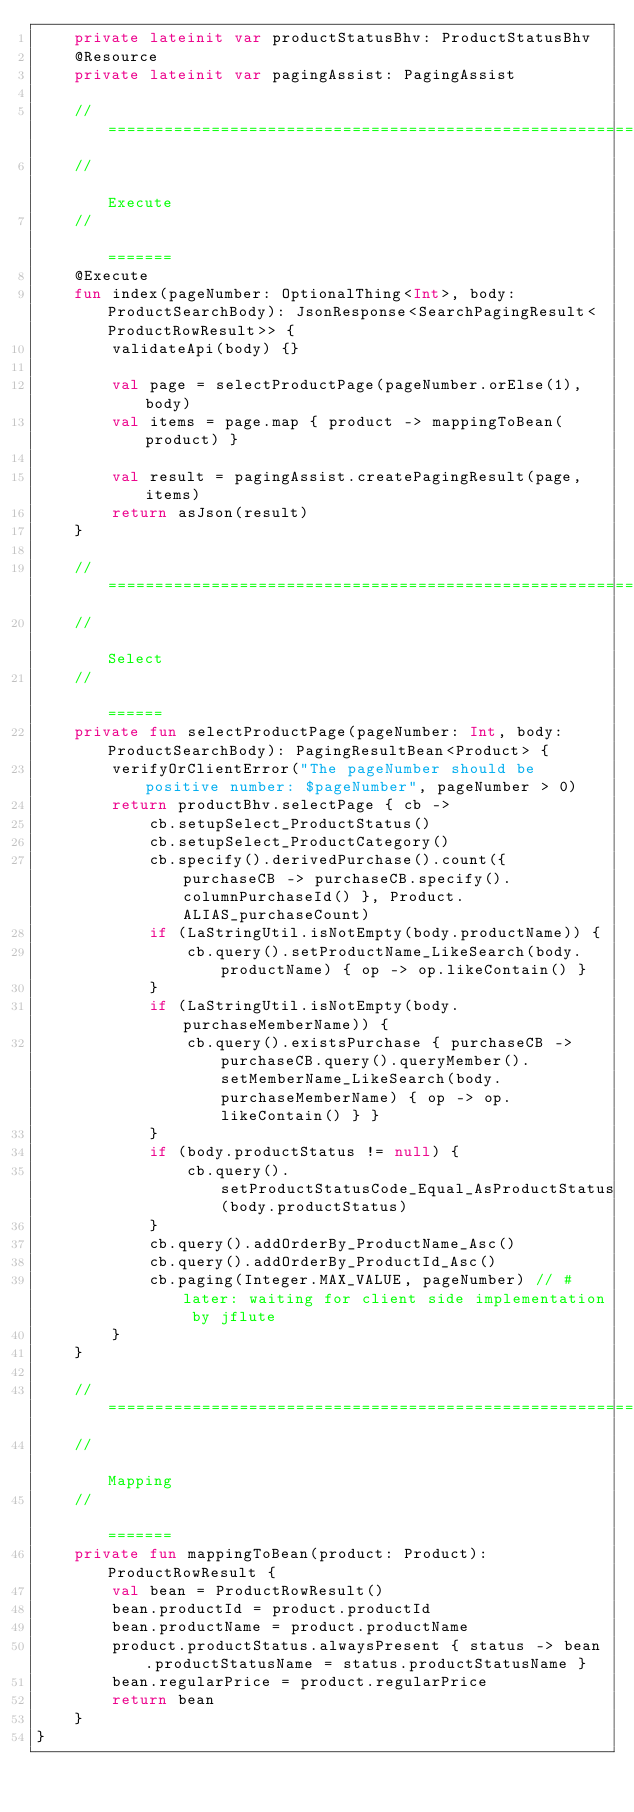<code> <loc_0><loc_0><loc_500><loc_500><_Kotlin_>    private lateinit var productStatusBhv: ProductStatusBhv
    @Resource
    private lateinit var pagingAssist: PagingAssist

    // ===================================================================================
    //                                                                             Execute
    //                                                                             =======
    @Execute
    fun index(pageNumber: OptionalThing<Int>, body: ProductSearchBody): JsonResponse<SearchPagingResult<ProductRowResult>> {
        validateApi(body) {}

        val page = selectProductPage(pageNumber.orElse(1), body)
        val items = page.map { product -> mappingToBean(product) }

        val result = pagingAssist.createPagingResult(page, items)
        return asJson(result)
    }

    // ===================================================================================
    //                                                                              Select
    //                                                                              ======
    private fun selectProductPage(pageNumber: Int, body: ProductSearchBody): PagingResultBean<Product> {
        verifyOrClientError("The pageNumber should be positive number: $pageNumber", pageNumber > 0)
        return productBhv.selectPage { cb ->
            cb.setupSelect_ProductStatus()
            cb.setupSelect_ProductCategory()
            cb.specify().derivedPurchase().count({ purchaseCB -> purchaseCB.specify().columnPurchaseId() }, Product.ALIAS_purchaseCount)
            if (LaStringUtil.isNotEmpty(body.productName)) {
                cb.query().setProductName_LikeSearch(body.productName) { op -> op.likeContain() }
            }
            if (LaStringUtil.isNotEmpty(body.purchaseMemberName)) {
                cb.query().existsPurchase { purchaseCB -> purchaseCB.query().queryMember().setMemberName_LikeSearch(body.purchaseMemberName) { op -> op.likeContain() } }
            }
            if (body.productStatus != null) {
                cb.query().setProductStatusCode_Equal_AsProductStatus(body.productStatus)
            }
            cb.query().addOrderBy_ProductName_Asc()
            cb.query().addOrderBy_ProductId_Asc()
            cb.paging(Integer.MAX_VALUE, pageNumber) // #later: waiting for client side implementation by jflute
        }
    }

    // ===================================================================================
    //                                                                             Mapping
    //                                                                             =======
    private fun mappingToBean(product: Product): ProductRowResult {
        val bean = ProductRowResult()
        bean.productId = product.productId
        bean.productName = product.productName
        product.productStatus.alwaysPresent { status -> bean.productStatusName = status.productStatusName }
        bean.regularPrice = product.regularPrice
        return bean
    }
}
</code> 